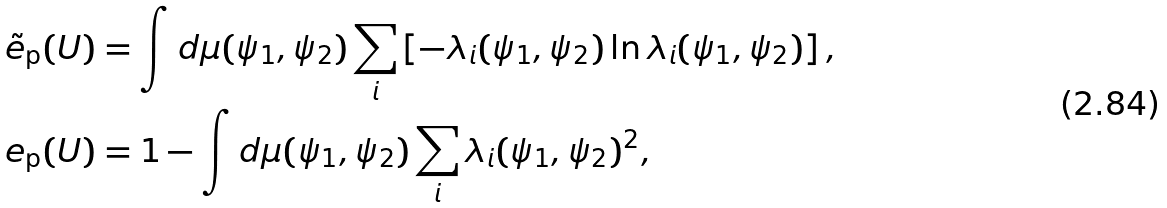Convert formula to latex. <formula><loc_0><loc_0><loc_500><loc_500>\tilde { e } _ { \text {p} } ( U ) & = \int d \mu ( \psi _ { 1 } , \psi _ { 2 } ) \sum _ { i } \left [ - \lambda _ { i } ( \psi _ { 1 } , \psi _ { 2 } ) \ln \lambda _ { i } ( \psi _ { 1 } , \psi _ { 2 } ) \right ] , \\ e _ { \text {p} } ( U ) & = 1 - \int d \mu ( \psi _ { 1 } , \psi _ { 2 } ) \sum _ { i } \lambda _ { i } ( \psi _ { 1 } , \psi _ { 2 } ) ^ { 2 } ,</formula> 